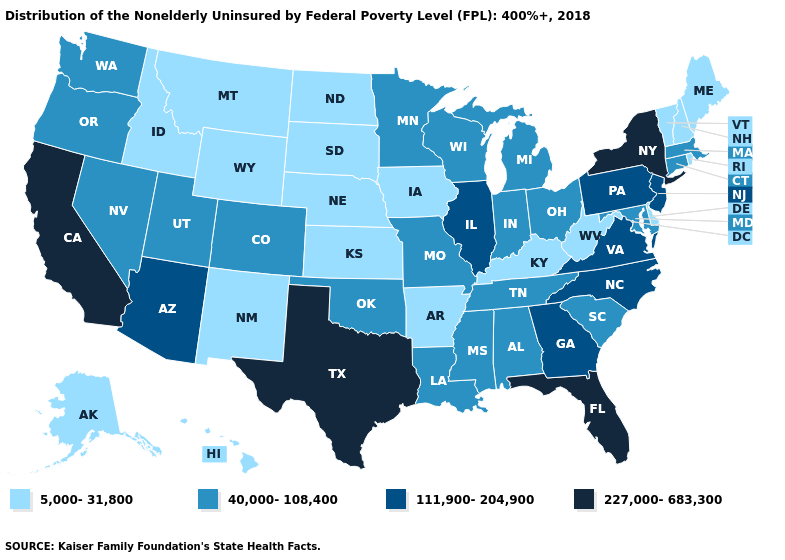What is the value of Louisiana?
Be succinct. 40,000-108,400. Name the states that have a value in the range 40,000-108,400?
Short answer required. Alabama, Colorado, Connecticut, Indiana, Louisiana, Maryland, Massachusetts, Michigan, Minnesota, Mississippi, Missouri, Nevada, Ohio, Oklahoma, Oregon, South Carolina, Tennessee, Utah, Washington, Wisconsin. How many symbols are there in the legend?
Give a very brief answer. 4. Name the states that have a value in the range 227,000-683,300?
Answer briefly. California, Florida, New York, Texas. What is the lowest value in the USA?
Give a very brief answer. 5,000-31,800. Does Iowa have the same value as North Carolina?
Concise answer only. No. Does West Virginia have a lower value than Alaska?
Answer briefly. No. Name the states that have a value in the range 111,900-204,900?
Concise answer only. Arizona, Georgia, Illinois, New Jersey, North Carolina, Pennsylvania, Virginia. What is the value of Wyoming?
Answer briefly. 5,000-31,800. Name the states that have a value in the range 227,000-683,300?
Be succinct. California, Florida, New York, Texas. What is the lowest value in states that border Michigan?
Answer briefly. 40,000-108,400. What is the lowest value in the West?
Give a very brief answer. 5,000-31,800. Which states have the highest value in the USA?
Be succinct. California, Florida, New York, Texas. Which states hav the highest value in the MidWest?
Keep it brief. Illinois. 